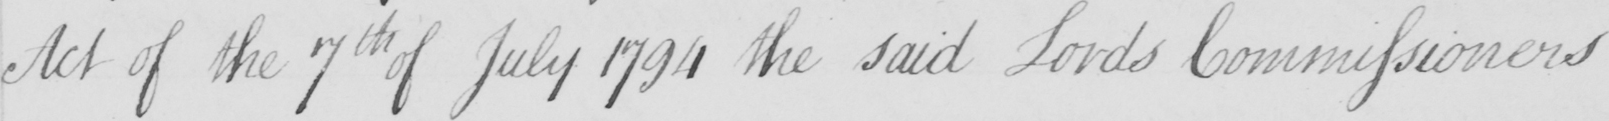What text is written in this handwritten line? Act of the 7th July 1794 the said Lords Commissioners 